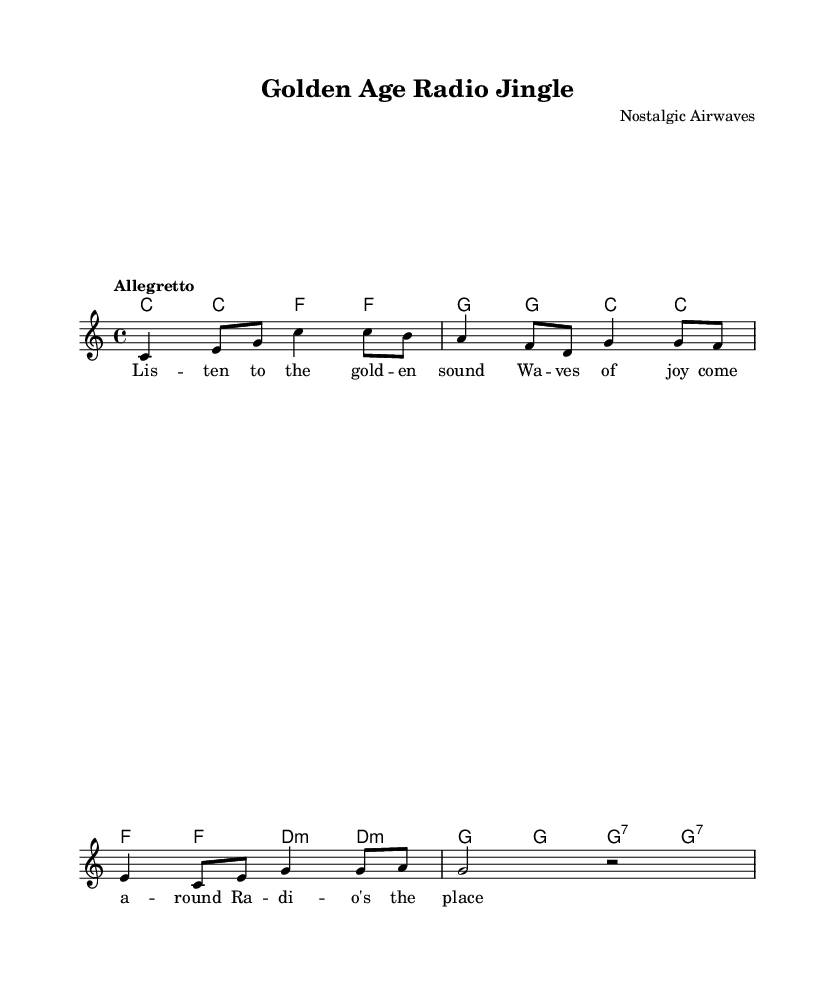What is the key signature of this music? The key signature indicated in the sheet music is C major, which is recognizable by the absence of any sharps or flats.
Answer: C major What is the time signature of this piece? The time signature is 4/4, which means each measure consists of four quarter note beats. This can be determined by looking at the signature at the beginning of the staff.
Answer: 4/4 What is the tempo marking for this score? The tempo marking is "Allegretto," which suggests a moderate speed, typically faster than "Andante" but slower than "Allegro." This is often prominently placed near the beginning of the sheet music.
Answer: Allegretto How many measures are in the melody section? By counting the measures shown in the melody line, the total is determined to be eight measures. Each segment separated by vertical lines represents a measure.
Answer: Eight What chords are used in the first four measures? The chords in the first four measures are C major and F major, identified by the chord names above the staff and their respective placements in the sheet music.
Answer: C major, F major What type of song is represented in this sheet music? The song is a jingle, often characterized by its catchy melody and lyrics that promote or entertain, typical of radio jingles from the 1950s and 60s. This can be inferred from the lyrics and style of the composition.
Answer: Jingle 